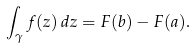Convert formula to latex. <formula><loc_0><loc_0><loc_500><loc_500>\int _ { \gamma } f ( z ) \, d z = F ( b ) - F ( a ) .</formula> 